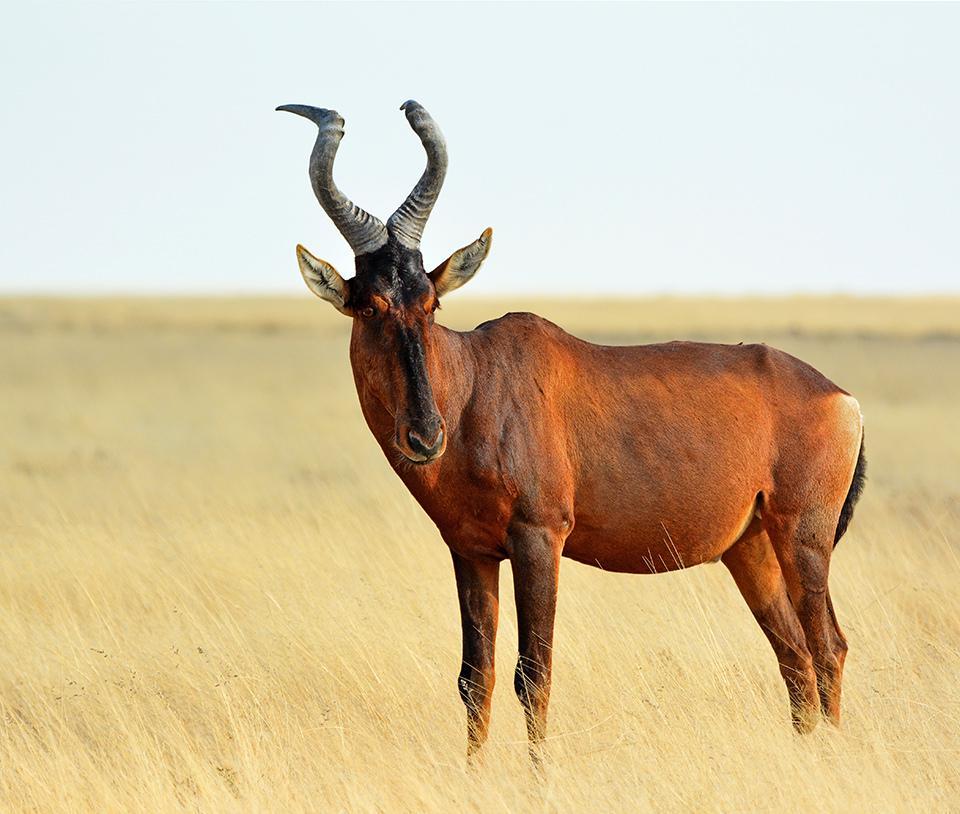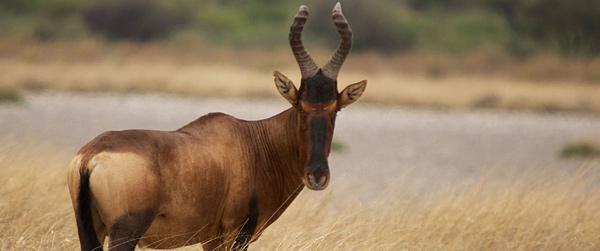The first image is the image on the left, the second image is the image on the right. Evaluate the accuracy of this statement regarding the images: "A hunter with a gun poses behind a downed horned animal in one image.". Is it true? Answer yes or no. No. The first image is the image on the left, the second image is the image on the right. Assess this claim about the two images: "In one of the images there is a person posing behind an antelope.". Correct or not? Answer yes or no. No. 